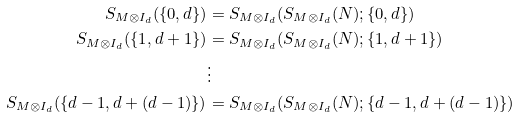Convert formula to latex. <formula><loc_0><loc_0><loc_500><loc_500>S _ { M \otimes I _ { d } } ( \{ 0 , d \} ) & = S _ { M \otimes I _ { d } } ( S _ { M \otimes I _ { d } } ( N ) ; \{ 0 , d \} ) \\ S _ { M \otimes I _ { d } } ( \{ 1 , d + 1 \} ) & = S _ { M \otimes I _ { d } } ( S _ { M \otimes I _ { d } } ( N ) ; \{ 1 , d + 1 \} ) \\ & \vdots \\ S _ { M \otimes I _ { d } } ( \{ d - 1 , d + ( d - 1 ) \} ) & = S _ { M \otimes I _ { d } } ( S _ { M \otimes I _ { d } } ( N ) ; \{ d - 1 , d + ( d - 1 ) \} ) \\</formula> 